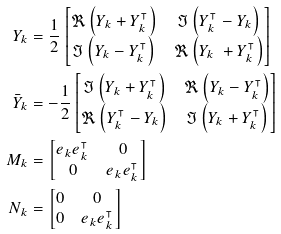Convert formula to latex. <formula><loc_0><loc_0><loc_500><loc_500>Y _ { k } & = \frac { 1 } { 2 } \begin{bmatrix} \Re \left ( Y _ { k } + Y _ { k } ^ { \intercal } \right ) & \Im \left ( Y _ { k } ^ { \intercal } - Y _ { k } \right ) \\ \Im \left ( Y _ { k } - Y _ { k } ^ { \intercal } \right ) & \Re \left ( Y _ { k } \ + Y _ { k } ^ { \intercal } \right ) \end{bmatrix} \\ \bar { Y } _ { k } & = - \frac { 1 } { 2 } \begin{bmatrix} \Im \left ( Y _ { k } + Y _ { k } ^ { \intercal } \right ) & \Re \left ( Y _ { k } - Y _ { k } ^ { \intercal } \right ) \\ \Re \left ( Y _ { k } ^ { \intercal } - Y _ { k } \right ) & \Im \left ( Y _ { k } + Y _ { k } ^ { \intercal } \right ) \end{bmatrix} \\ M _ { k } & = \begin{bmatrix} e _ { k } e _ { k } ^ { \intercal } & 0 \\ 0 & e _ { k } e _ { k } ^ { \intercal } \end{bmatrix} \\ N _ { k } & = \begin{bmatrix} 0 & 0 \\ 0 & e _ { k } e _ { k } ^ { \intercal } \end{bmatrix}</formula> 